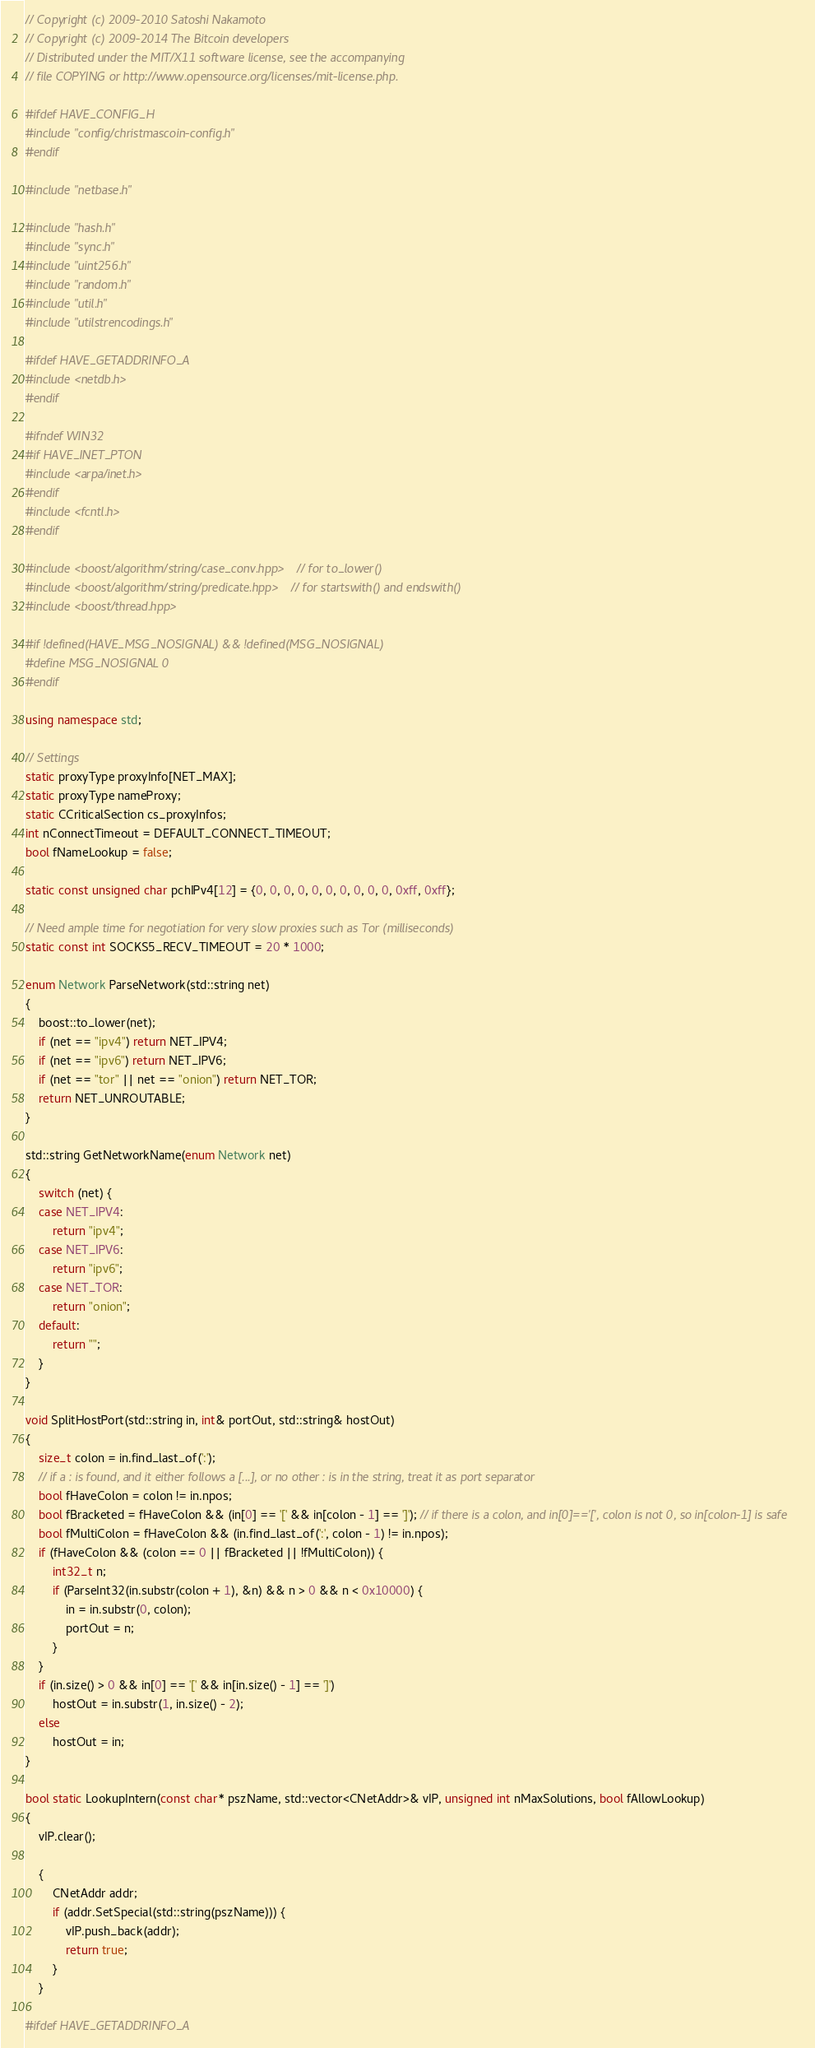<code> <loc_0><loc_0><loc_500><loc_500><_C++_>// Copyright (c) 2009-2010 Satoshi Nakamoto
// Copyright (c) 2009-2014 The Bitcoin developers
// Distributed under the MIT/X11 software license, see the accompanying
// file COPYING or http://www.opensource.org/licenses/mit-license.php.

#ifdef HAVE_CONFIG_H
#include "config/christmascoin-config.h"
#endif

#include "netbase.h"

#include "hash.h"
#include "sync.h"
#include "uint256.h"
#include "random.h"
#include "util.h"
#include "utilstrencodings.h"

#ifdef HAVE_GETADDRINFO_A
#include <netdb.h>
#endif

#ifndef WIN32
#if HAVE_INET_PTON
#include <arpa/inet.h>
#endif
#include <fcntl.h>
#endif

#include <boost/algorithm/string/case_conv.hpp> // for to_lower()
#include <boost/algorithm/string/predicate.hpp> // for startswith() and endswith()
#include <boost/thread.hpp>

#if !defined(HAVE_MSG_NOSIGNAL) && !defined(MSG_NOSIGNAL)
#define MSG_NOSIGNAL 0
#endif

using namespace std;

// Settings
static proxyType proxyInfo[NET_MAX];
static proxyType nameProxy;
static CCriticalSection cs_proxyInfos;
int nConnectTimeout = DEFAULT_CONNECT_TIMEOUT;
bool fNameLookup = false;

static const unsigned char pchIPv4[12] = {0, 0, 0, 0, 0, 0, 0, 0, 0, 0, 0xff, 0xff};

// Need ample time for negotiation for very slow proxies such as Tor (milliseconds)
static const int SOCKS5_RECV_TIMEOUT = 20 * 1000;

enum Network ParseNetwork(std::string net)
{
    boost::to_lower(net);
    if (net == "ipv4") return NET_IPV4;
    if (net == "ipv6") return NET_IPV6;
    if (net == "tor" || net == "onion") return NET_TOR;
    return NET_UNROUTABLE;
}

std::string GetNetworkName(enum Network net)
{
    switch (net) {
    case NET_IPV4:
        return "ipv4";
    case NET_IPV6:
        return "ipv6";
    case NET_TOR:
        return "onion";
    default:
        return "";
    }
}

void SplitHostPort(std::string in, int& portOut, std::string& hostOut)
{
    size_t colon = in.find_last_of(':');
    // if a : is found, and it either follows a [...], or no other : is in the string, treat it as port separator
    bool fHaveColon = colon != in.npos;
    bool fBracketed = fHaveColon && (in[0] == '[' && in[colon - 1] == ']'); // if there is a colon, and in[0]=='[', colon is not 0, so in[colon-1] is safe
    bool fMultiColon = fHaveColon && (in.find_last_of(':', colon - 1) != in.npos);
    if (fHaveColon && (colon == 0 || fBracketed || !fMultiColon)) {
        int32_t n;
        if (ParseInt32(in.substr(colon + 1), &n) && n > 0 && n < 0x10000) {
            in = in.substr(0, colon);
            portOut = n;
        }
    }
    if (in.size() > 0 && in[0] == '[' && in[in.size() - 1] == ']')
        hostOut = in.substr(1, in.size() - 2);
    else
        hostOut = in;
}

bool static LookupIntern(const char* pszName, std::vector<CNetAddr>& vIP, unsigned int nMaxSolutions, bool fAllowLookup)
{
    vIP.clear();

    {
        CNetAddr addr;
        if (addr.SetSpecial(std::string(pszName))) {
            vIP.push_back(addr);
            return true;
        }
    }

#ifdef HAVE_GETADDRINFO_A</code> 